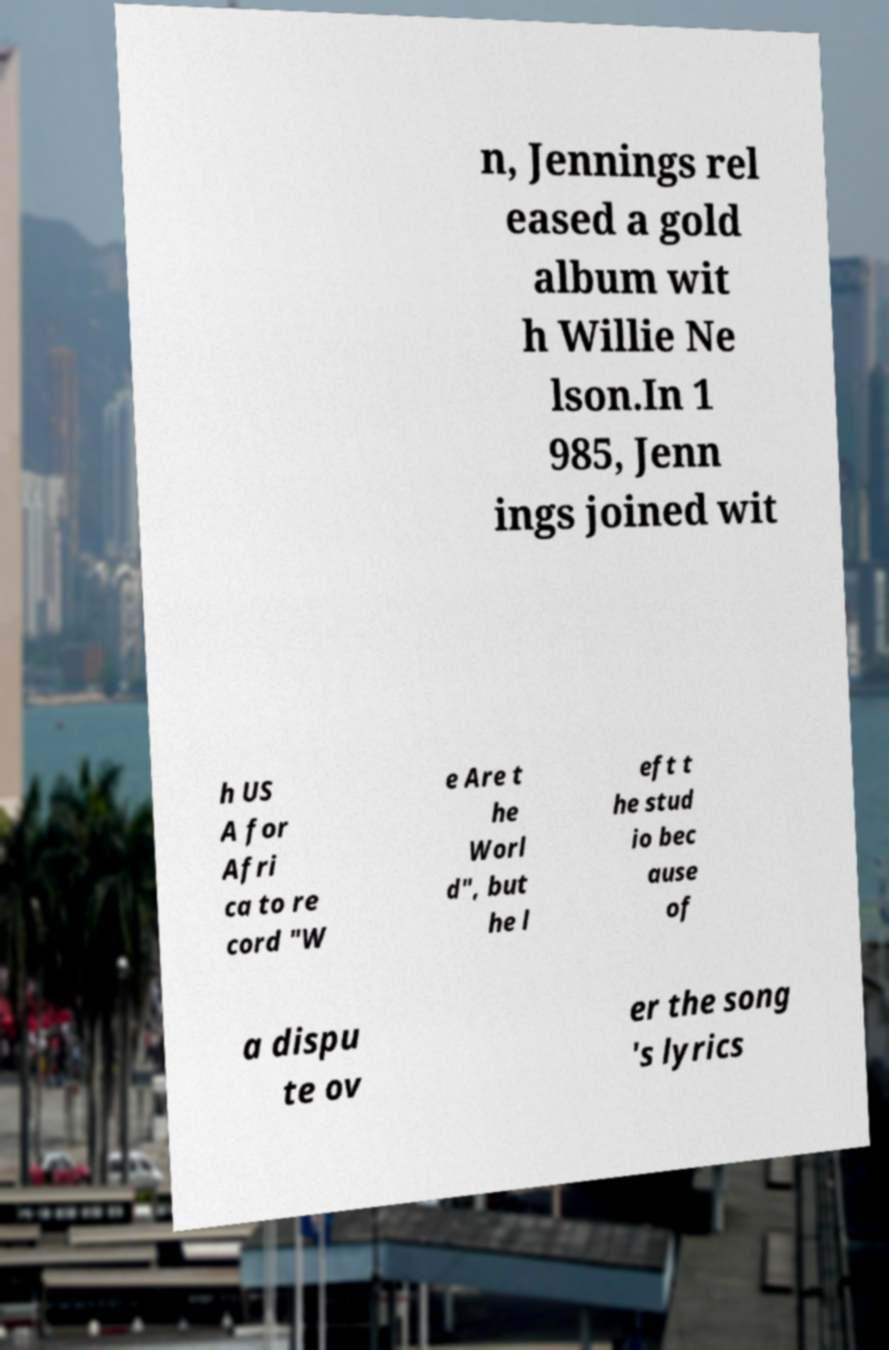I need the written content from this picture converted into text. Can you do that? n, Jennings rel eased a gold album wit h Willie Ne lson.In 1 985, Jenn ings joined wit h US A for Afri ca to re cord "W e Are t he Worl d", but he l eft t he stud io bec ause of a dispu te ov er the song 's lyrics 